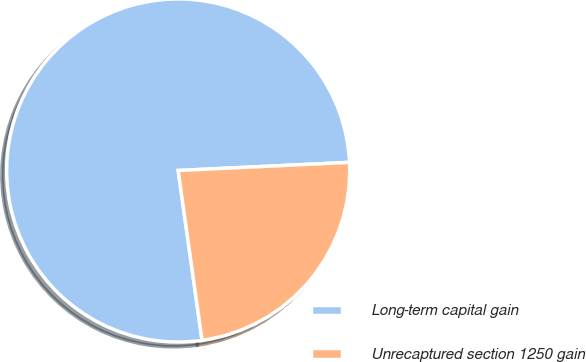Convert chart to OTSL. <chart><loc_0><loc_0><loc_500><loc_500><pie_chart><fcel>Long-term capital gain<fcel>Unrecaptured section 1250 gain<nl><fcel>76.47%<fcel>23.53%<nl></chart> 